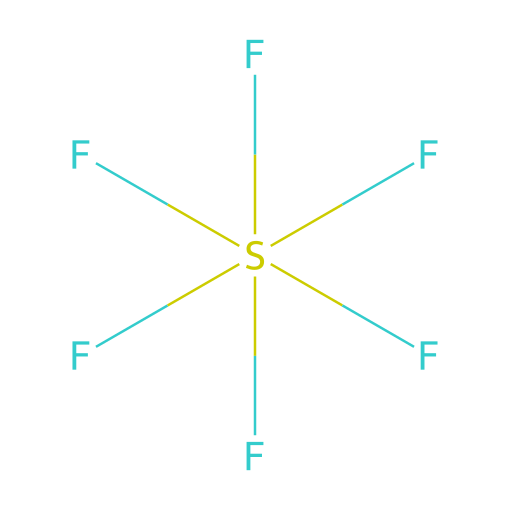What is the total number of fluorine atoms in this compound? The SMILES representation shows six fluorine atoms attached to the sulfur atom, indicated by the notation "F" appearing six times in the structure.
Answer: six What is the central atom in this chemical structure? The chemical structure indicates that sulfur (S) is bonded to the six fluorine atoms, making it the central atom in this compound.
Answer: sulfur How many bonds does the central sulfur atom have? In the structure, the sulfur atom is bound to six fluorine atoms, which means it forms six single bonds to the fluorine atoms, therefore it has six bonds.
Answer: six Is this compound polar or nonpolar? Given the symmetrical arrangement of the six fluorine atoms around the sulfur atom, this compound is nonpolar as the dipoles from each F-S bond cancel out.
Answer: nonpolar What is the physical state of sulfur hexafluoride at room temperature? This compound is a gas at room temperature due to its low molecular weight and high fluorine content, making it less dense than air and a gas under standard conditions.
Answer: gas What type of compound is sulfur hexafluoride primarily used in? The structure's stability and electrical insulation properties make sulfur hexafluoride primarily used in electrical equipment, such as switchgear and circuit breakers.
Answer: electrical equipment Can this compound be classified as an alkane, alkene, or halide? The compound is classified as a halide since it consists of sulfur and multiple fluorine atoms, and it does not fit the structures of alkanes or alkenes.
Answer: halide 